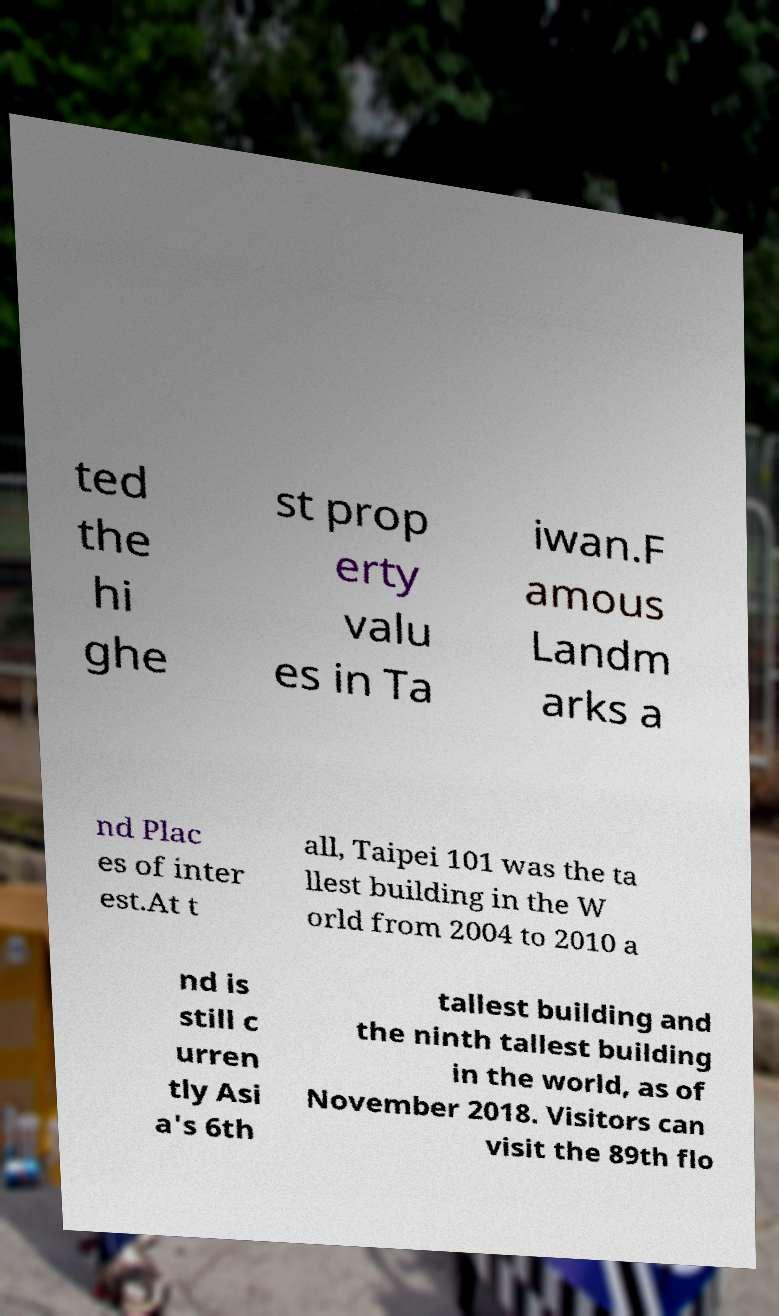Can you accurately transcribe the text from the provided image for me? ted the hi ghe st prop erty valu es in Ta iwan.F amous Landm arks a nd Plac es of inter est.At t all, Taipei 101 was the ta llest building in the W orld from 2004 to 2010 a nd is still c urren tly Asi a's 6th tallest building and the ninth tallest building in the world, as of November 2018. Visitors can visit the 89th flo 